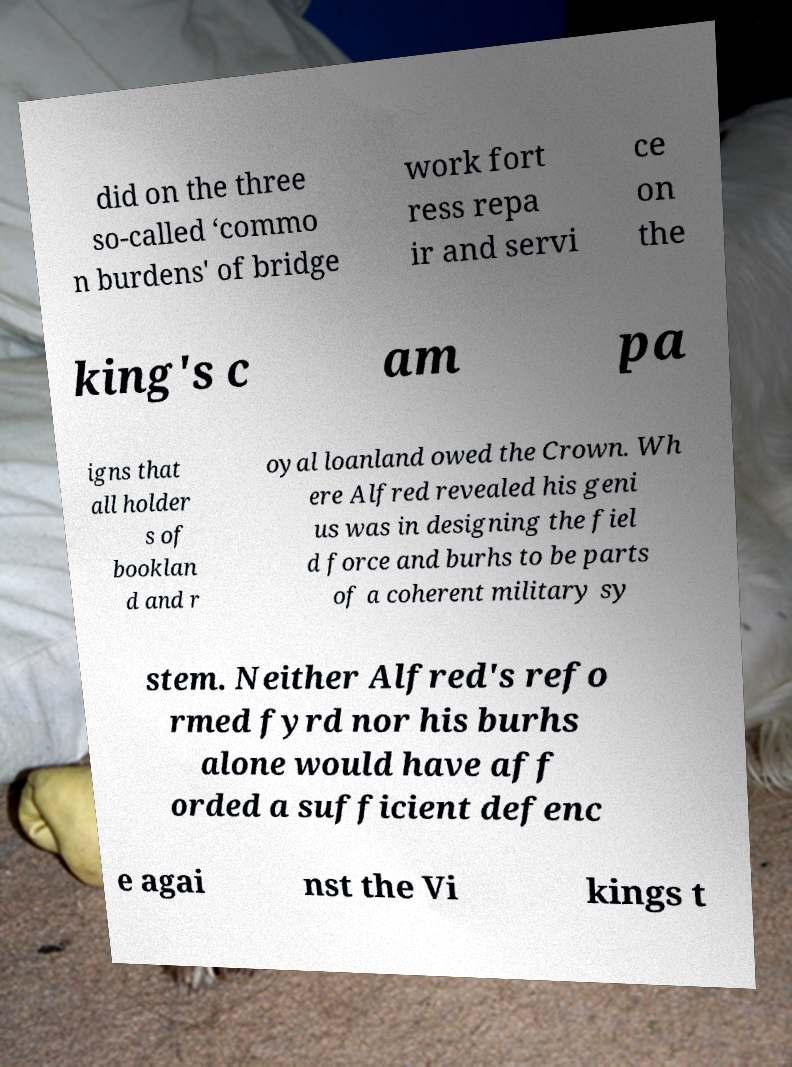Could you extract and type out the text from this image? did on the three so-called ‘commo n burdens' of bridge work fort ress repa ir and servi ce on the king's c am pa igns that all holder s of booklan d and r oyal loanland owed the Crown. Wh ere Alfred revealed his geni us was in designing the fiel d force and burhs to be parts of a coherent military sy stem. Neither Alfred's refo rmed fyrd nor his burhs alone would have aff orded a sufficient defenc e agai nst the Vi kings t 